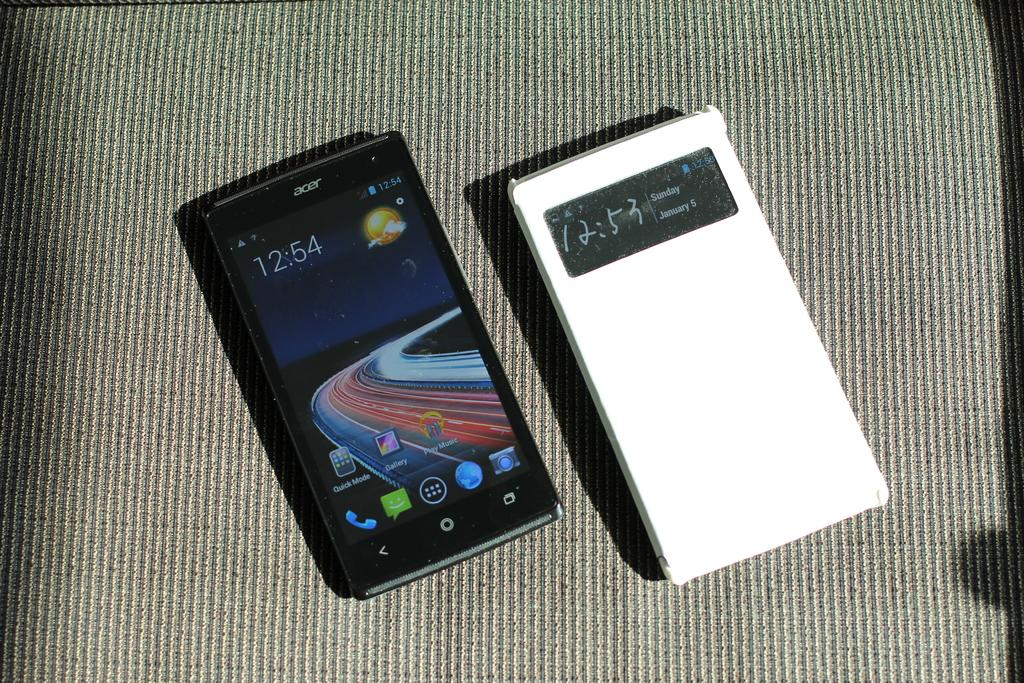<image>
Write a terse but informative summary of the picture. Two devices beside each other, one is a black Acer phone with the time of 12:54 displayed. 